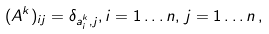Convert formula to latex. <formula><loc_0><loc_0><loc_500><loc_500>( A ^ { k } ) _ { i j } = \delta _ { a _ { i } ^ { k } , j } , i = 1 \dots n , \, j = 1 \dots n \, ,</formula> 